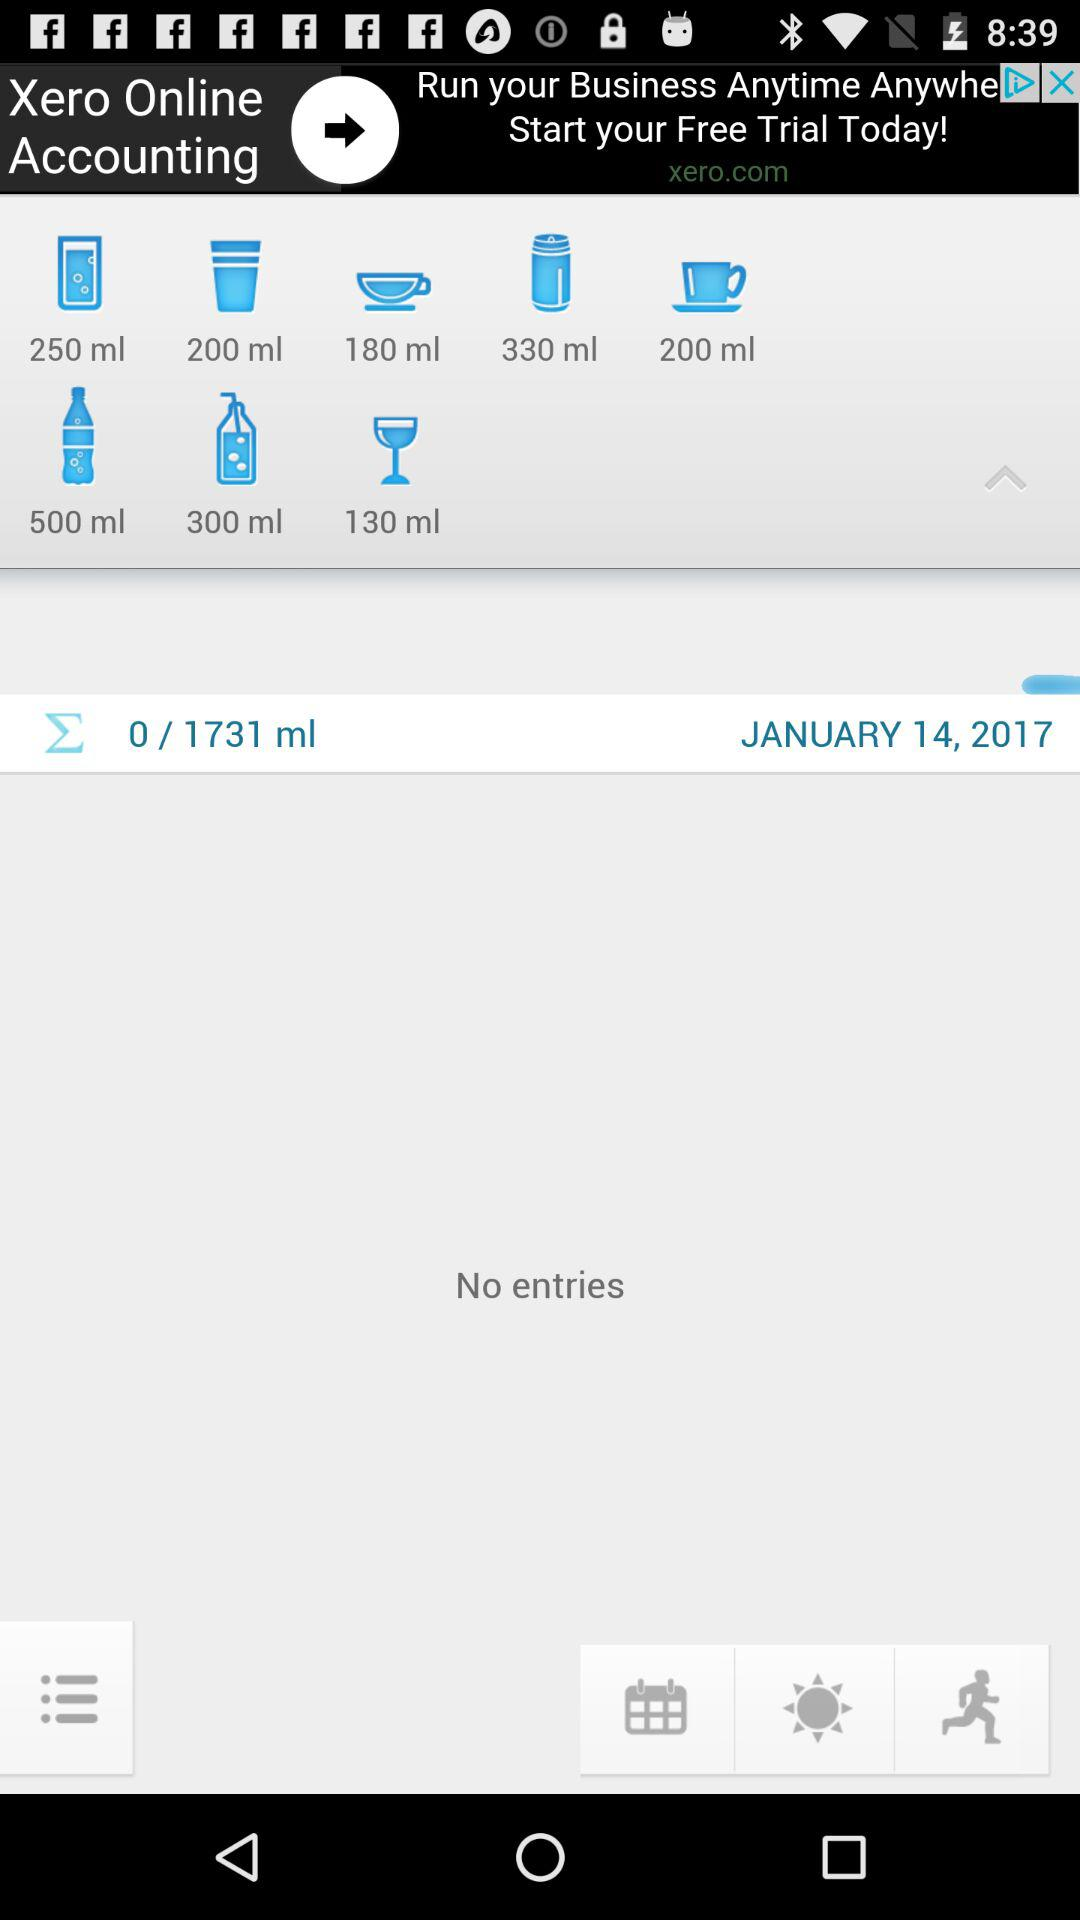What is the date? The date is January 14, 2017. 